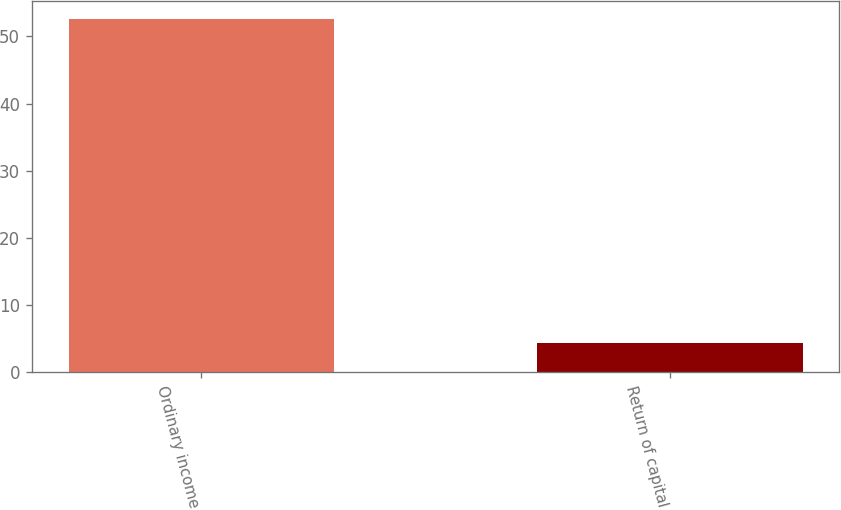<chart> <loc_0><loc_0><loc_500><loc_500><bar_chart><fcel>Ordinary income<fcel>Return of capital<nl><fcel>52.6<fcel>4.4<nl></chart> 